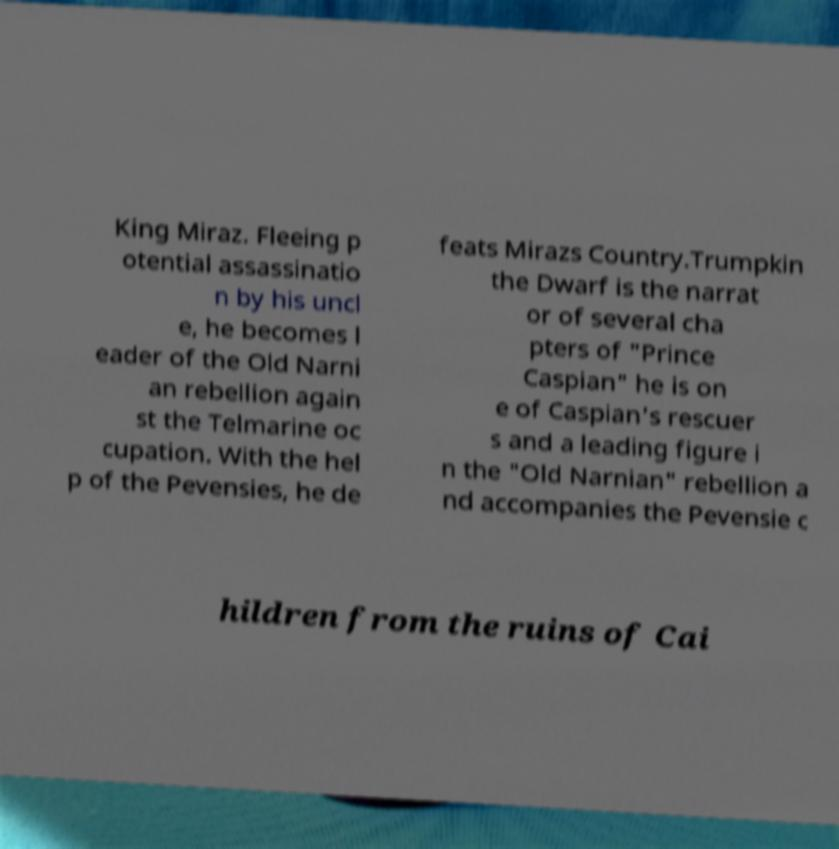Could you extract and type out the text from this image? King Miraz. Fleeing p otential assassinatio n by his uncl e, he becomes l eader of the Old Narni an rebellion again st the Telmarine oc cupation. With the hel p of the Pevensies, he de feats Mirazs Country.Trumpkin the Dwarf is the narrat or of several cha pters of "Prince Caspian" he is on e of Caspian's rescuer s and a leading figure i n the "Old Narnian" rebellion a nd accompanies the Pevensie c hildren from the ruins of Cai 